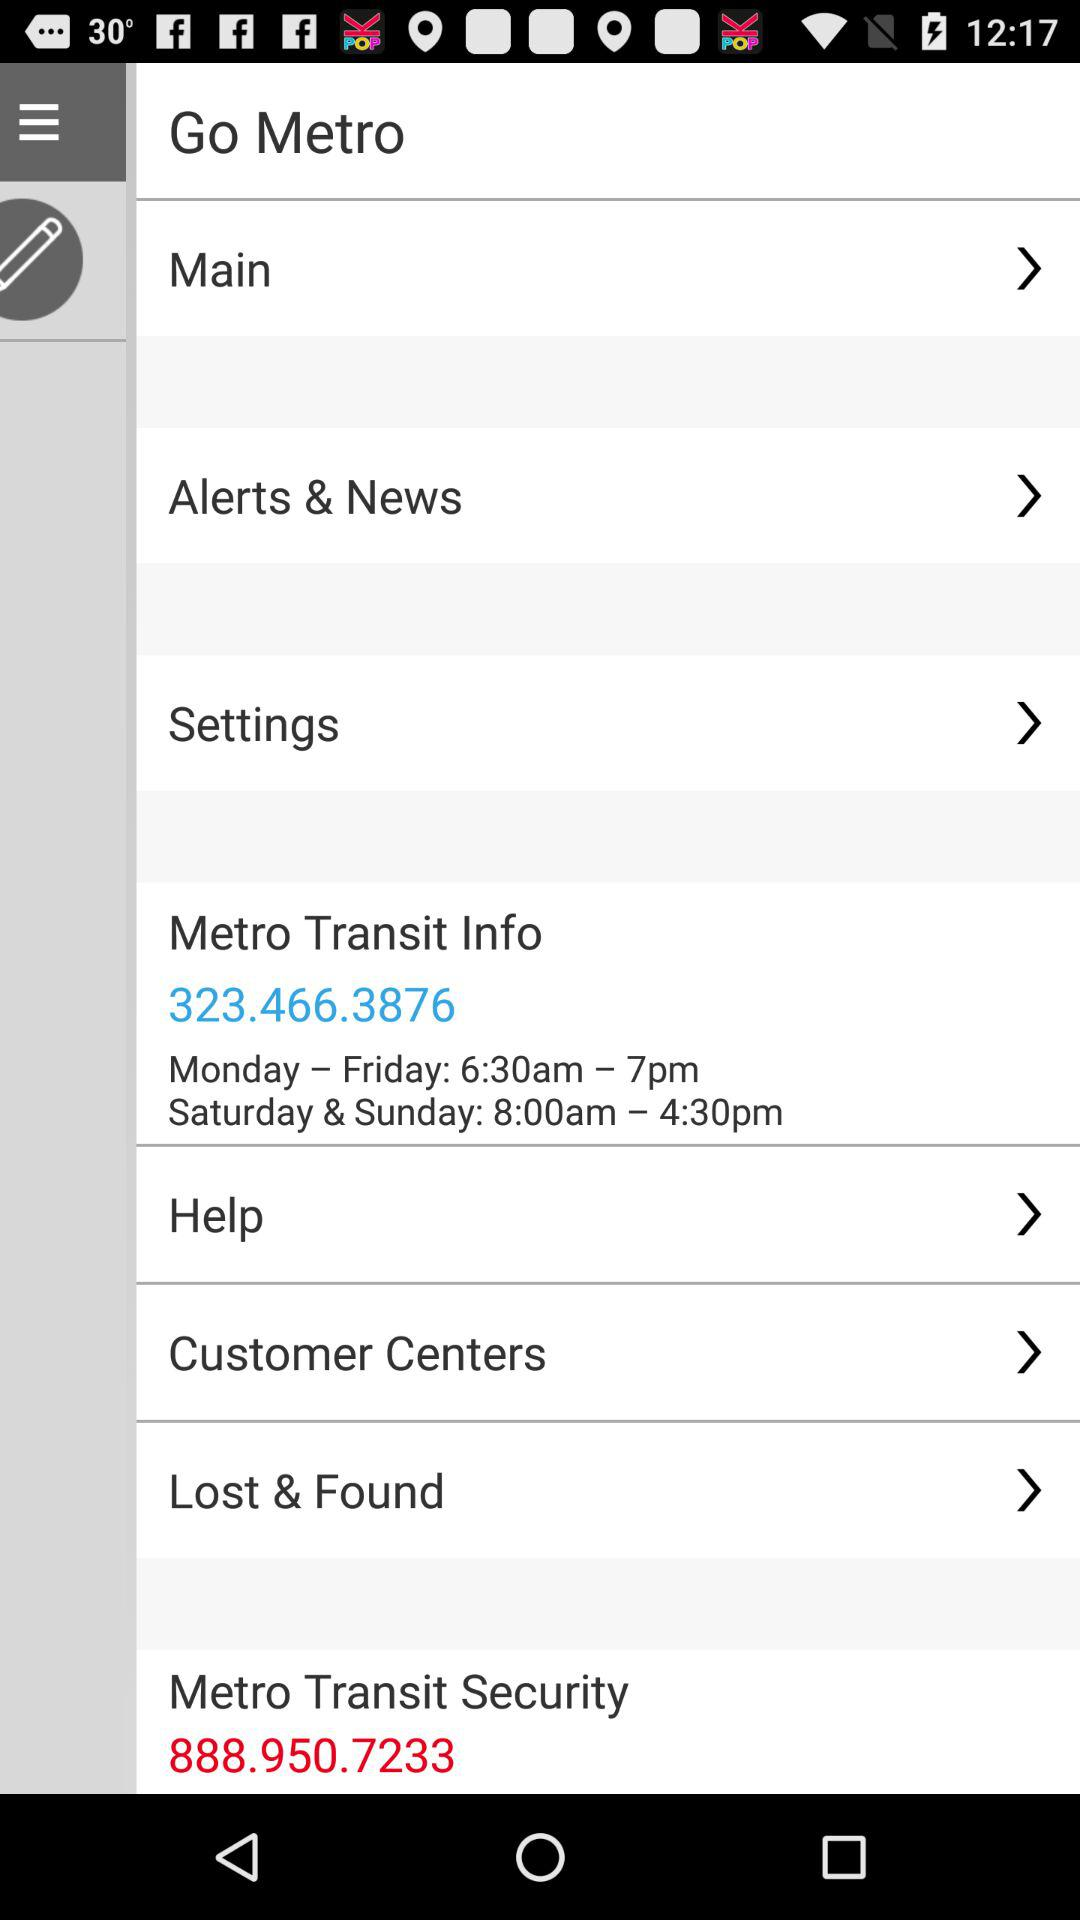What is the security contact number? The contact number is 888.950.7233. 